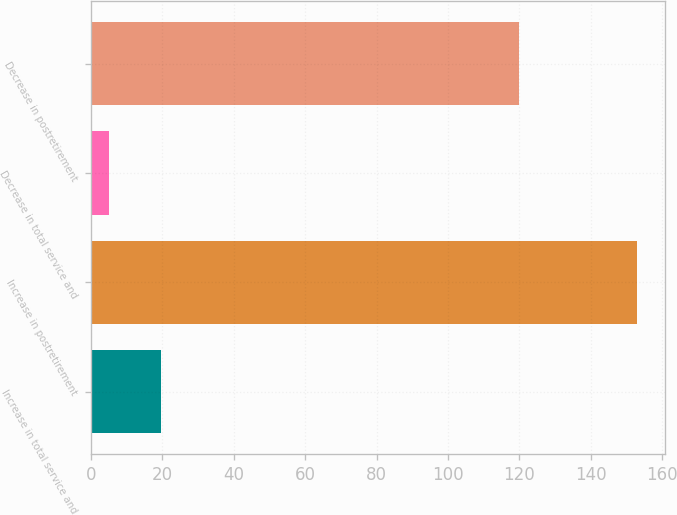Convert chart to OTSL. <chart><loc_0><loc_0><loc_500><loc_500><bar_chart><fcel>Increase in total service and<fcel>Increase in postretirement<fcel>Decrease in total service and<fcel>Decrease in postretirement<nl><fcel>19.8<fcel>153<fcel>5<fcel>120<nl></chart> 